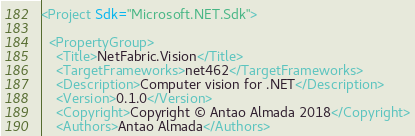<code> <loc_0><loc_0><loc_500><loc_500><_XML_><Project Sdk="Microsoft.NET.Sdk">
  
  <PropertyGroup>
    <Title>NetFabric.Vision</Title>
    <TargetFrameworks>net462</TargetFrameworks>
    <Description>Computer vision for .NET</Description>
    <Version>0.1.0</Version>
    <Copyright>Copyright © Antao Almada 2018</Copyright>
    <Authors>Antao Almada</Authors></code> 